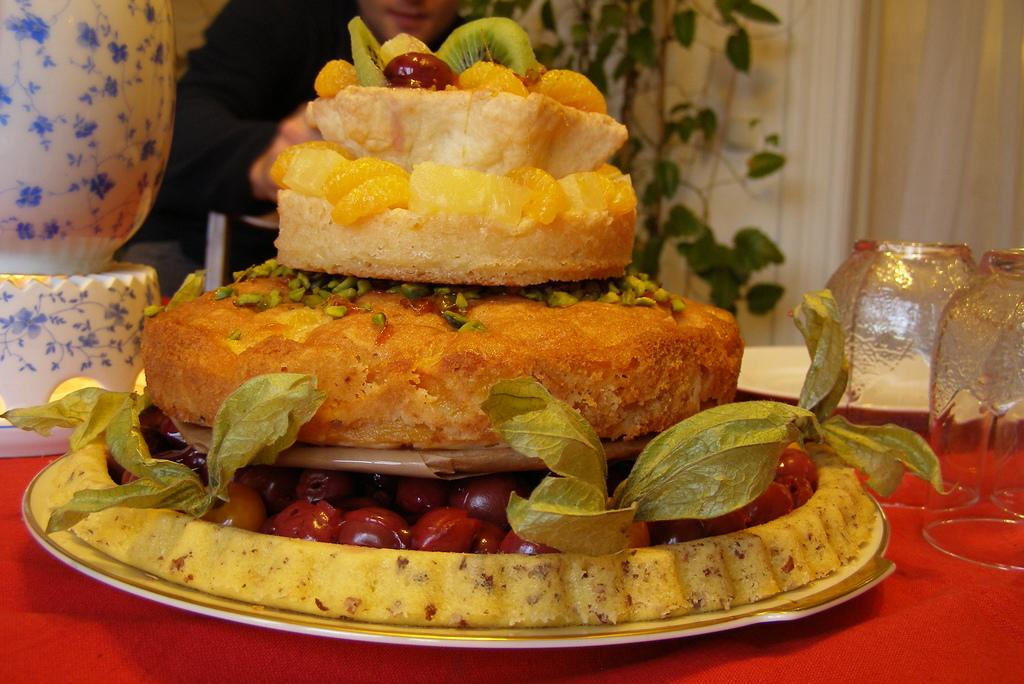What can be found on the table in the image? There are food items, glasses, and a plate on the table. Are there any other objects on the table? Yes, there are other objects on the table. Can you describe the person behind the table? There is a person behind the table, but their appearance or actions are not specified in the facts. What type of vegetation is present in the image? There is a plant in the image. What can be seen in the background of the image? There are curtains in the image. How many clovers are visible on the table in the image? There are no clovers present on the table in the image. What type of letter is the person behind the table holding? There is no mention of a letter or any written material in the image. 